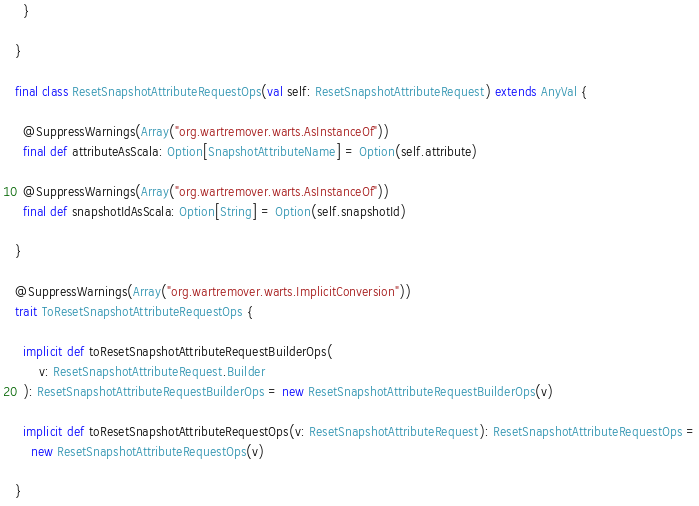<code> <loc_0><loc_0><loc_500><loc_500><_Scala_>  }

}

final class ResetSnapshotAttributeRequestOps(val self: ResetSnapshotAttributeRequest) extends AnyVal {

  @SuppressWarnings(Array("org.wartremover.warts.AsInstanceOf"))
  final def attributeAsScala: Option[SnapshotAttributeName] = Option(self.attribute)

  @SuppressWarnings(Array("org.wartremover.warts.AsInstanceOf"))
  final def snapshotIdAsScala: Option[String] = Option(self.snapshotId)

}

@SuppressWarnings(Array("org.wartremover.warts.ImplicitConversion"))
trait ToResetSnapshotAttributeRequestOps {

  implicit def toResetSnapshotAttributeRequestBuilderOps(
      v: ResetSnapshotAttributeRequest.Builder
  ): ResetSnapshotAttributeRequestBuilderOps = new ResetSnapshotAttributeRequestBuilderOps(v)

  implicit def toResetSnapshotAttributeRequestOps(v: ResetSnapshotAttributeRequest): ResetSnapshotAttributeRequestOps =
    new ResetSnapshotAttributeRequestOps(v)

}
</code> 